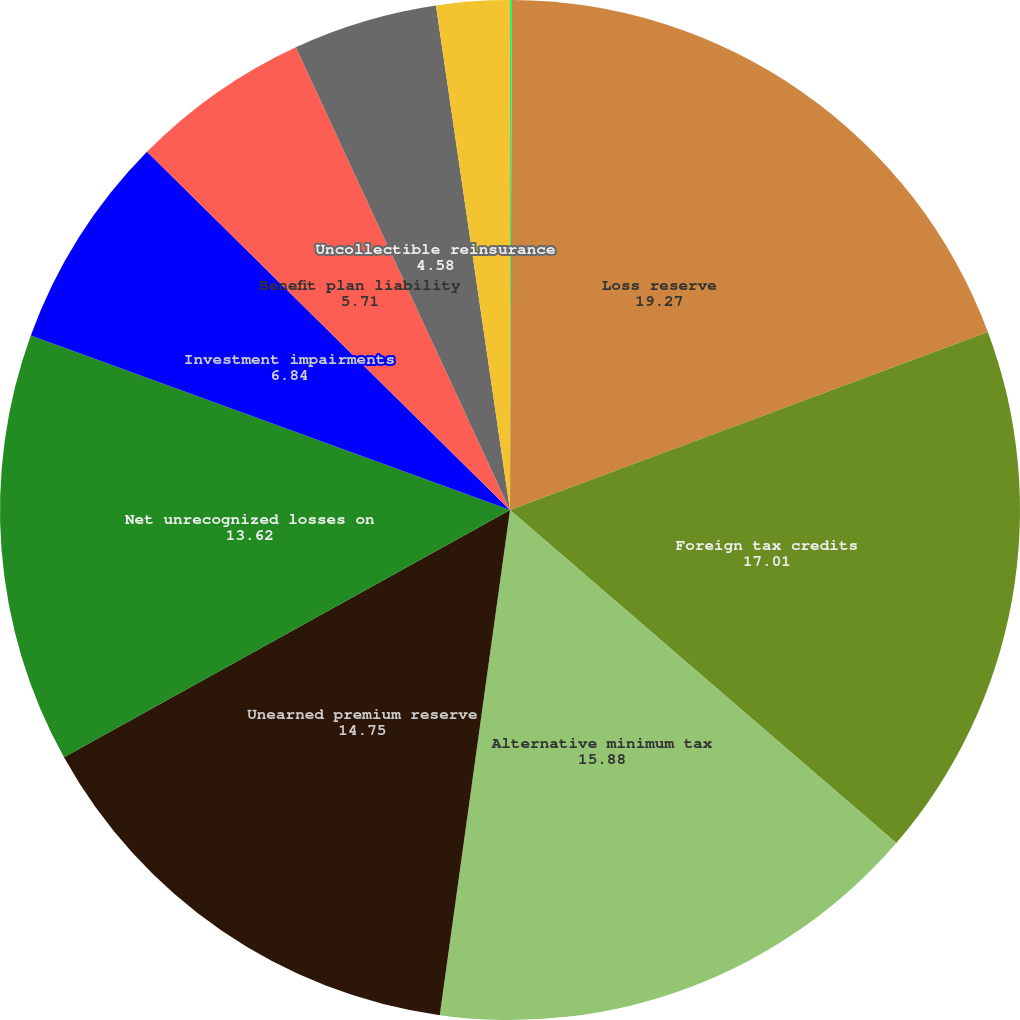Convert chart. <chart><loc_0><loc_0><loc_500><loc_500><pie_chart><fcel>(Dollars in thousands)<fcel>Loss reserve<fcel>Foreign tax credits<fcel>Alternative minimum tax<fcel>Unearned premium reserve<fcel>Net unrecognized losses on<fcel>Investment impairments<fcel>Benefit plan liability<fcel>Uncollectible reinsurance<fcel>Net operating loss<nl><fcel>0.06%<fcel>19.27%<fcel>17.01%<fcel>15.88%<fcel>14.75%<fcel>13.62%<fcel>6.84%<fcel>5.71%<fcel>4.58%<fcel>2.32%<nl></chart> 